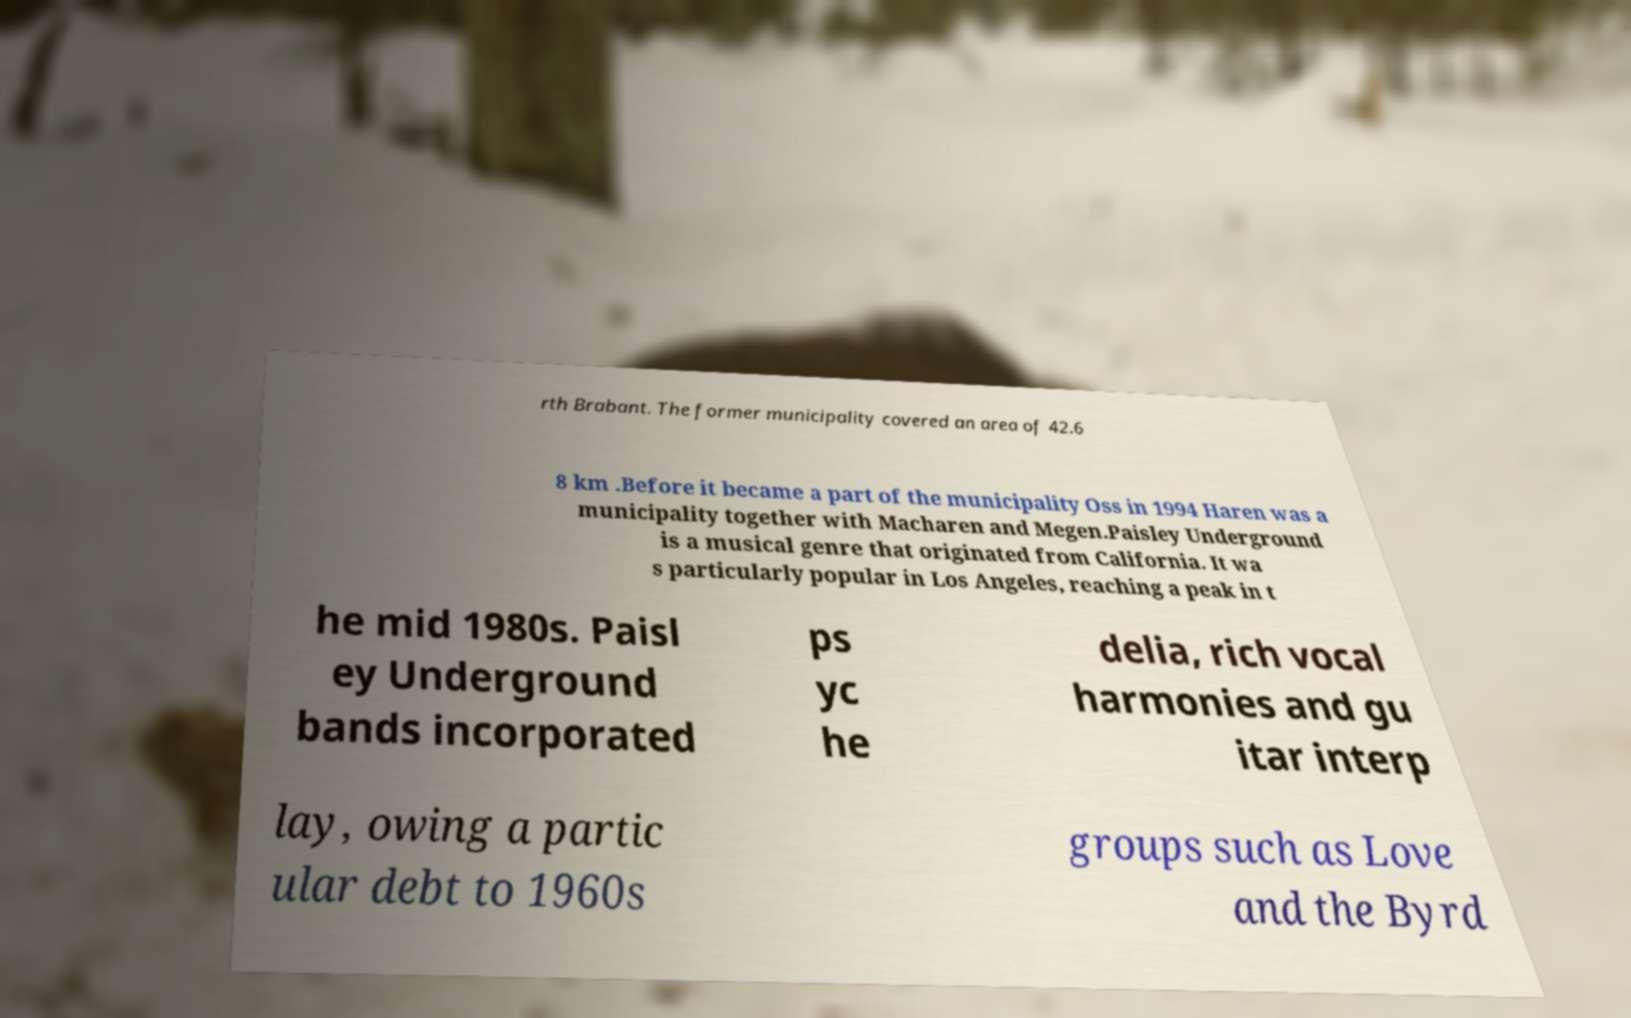Can you accurately transcribe the text from the provided image for me? rth Brabant. The former municipality covered an area of 42.6 8 km .Before it became a part of the municipality Oss in 1994 Haren was a municipality together with Macharen and Megen.Paisley Underground is a musical genre that originated from California. It wa s particularly popular in Los Angeles, reaching a peak in t he mid 1980s. Paisl ey Underground bands incorporated ps yc he delia, rich vocal harmonies and gu itar interp lay, owing a partic ular debt to 1960s groups such as Love and the Byrd 